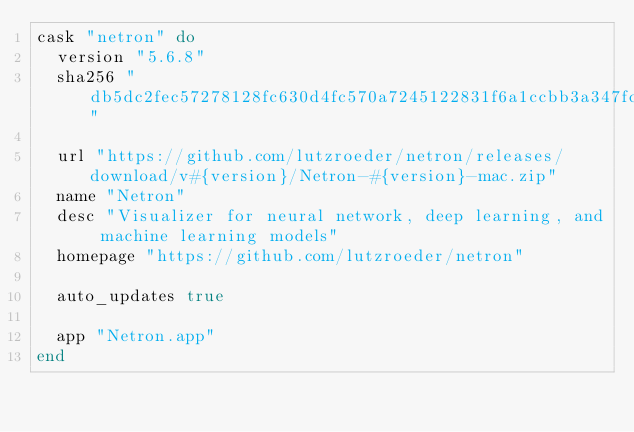<code> <loc_0><loc_0><loc_500><loc_500><_Ruby_>cask "netron" do
  version "5.6.8"
  sha256 "db5dc2fec57278128fc630d4fc570a7245122831f6a1ccbb3a347fccd01e50f4"

  url "https://github.com/lutzroeder/netron/releases/download/v#{version}/Netron-#{version}-mac.zip"
  name "Netron"
  desc "Visualizer for neural network, deep learning, and machine learning models"
  homepage "https://github.com/lutzroeder/netron"

  auto_updates true

  app "Netron.app"
end
</code> 